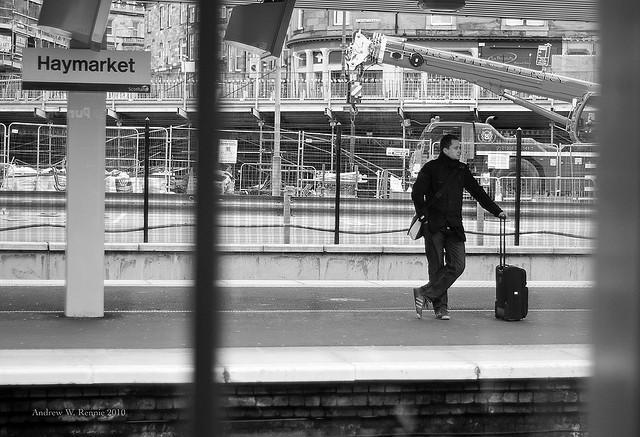How many people are there?
Give a very brief answer. 1. How many suitcases are in the photo?
Give a very brief answer. 1. How many pink umbrellas are in this image?
Give a very brief answer. 0. 